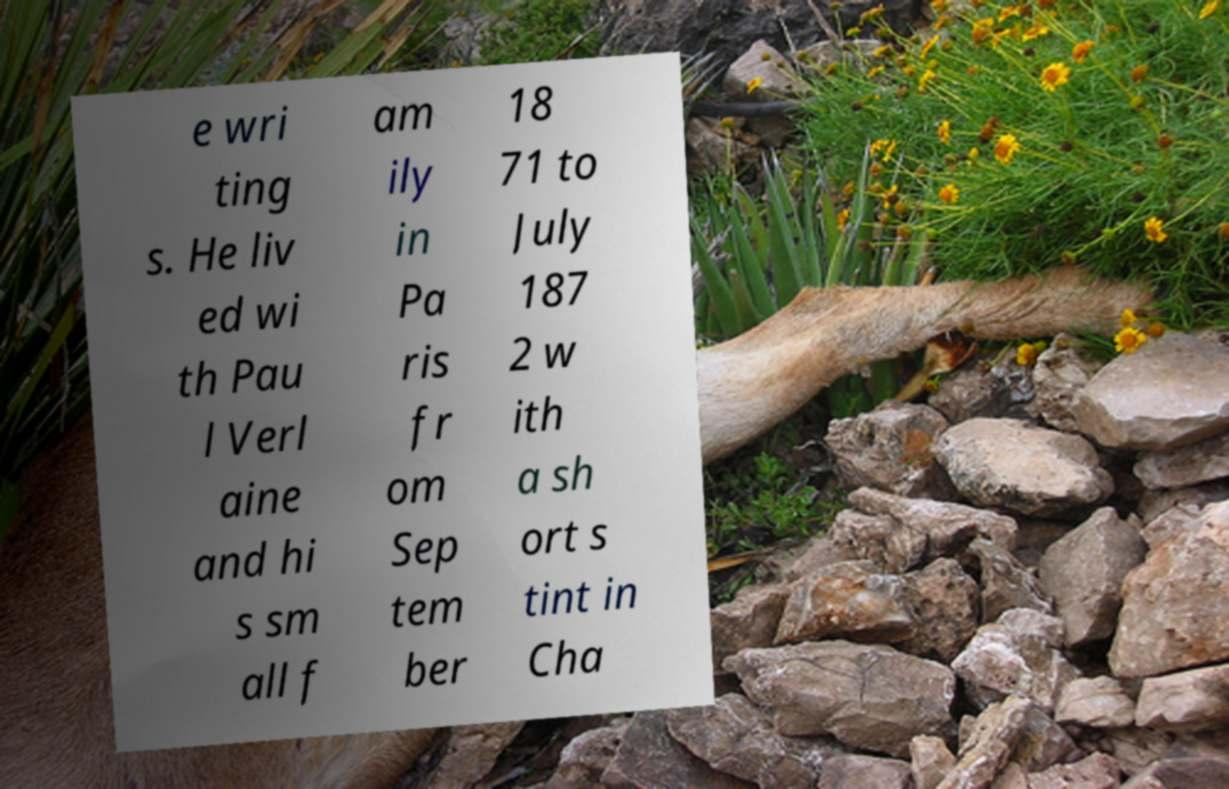Can you accurately transcribe the text from the provided image for me? e wri ting s. He liv ed wi th Pau l Verl aine and hi s sm all f am ily in Pa ris fr om Sep tem ber 18 71 to July 187 2 w ith a sh ort s tint in Cha 